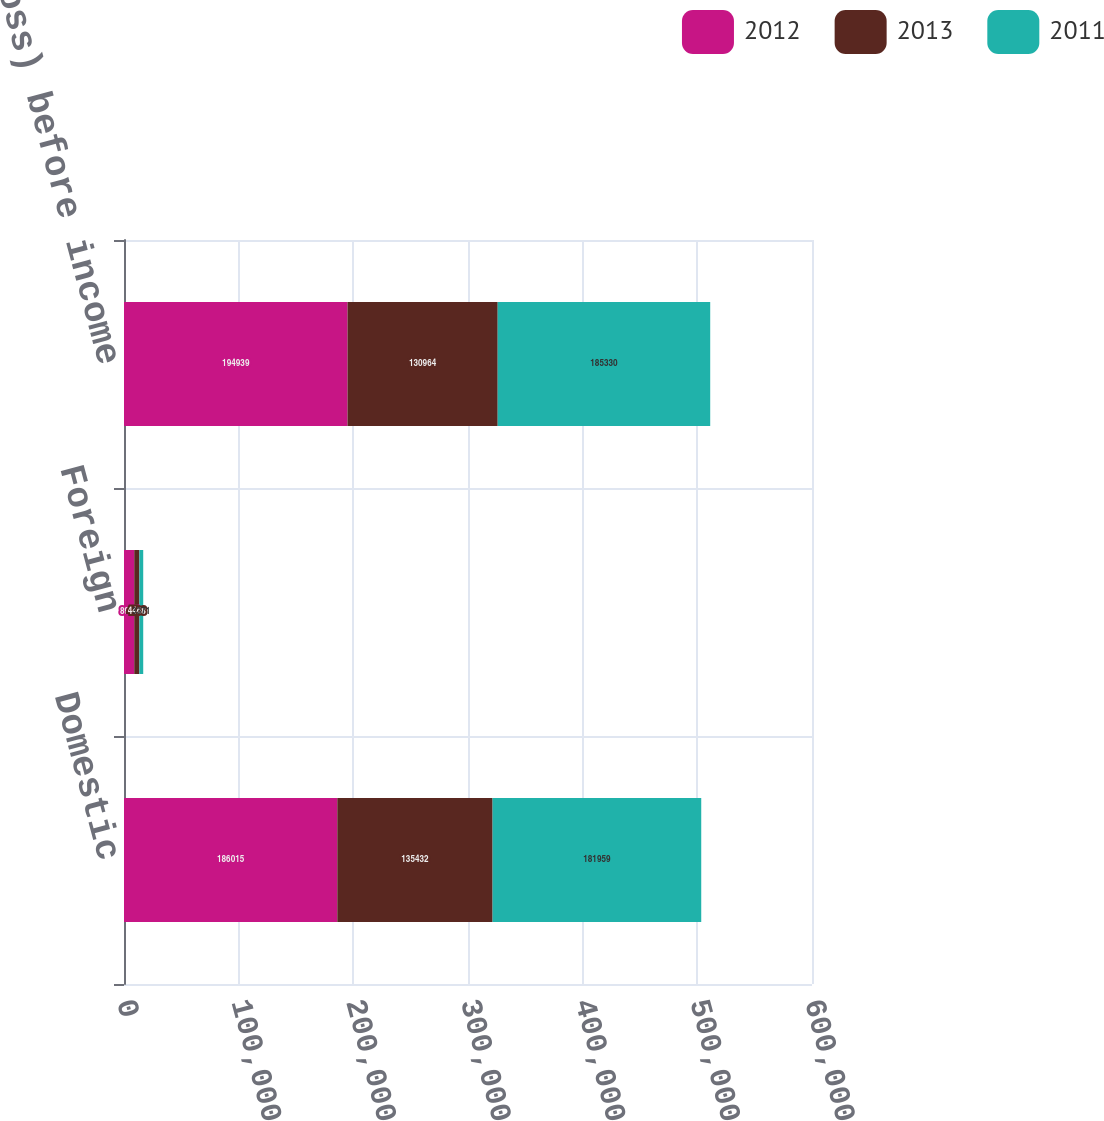<chart> <loc_0><loc_0><loc_500><loc_500><stacked_bar_chart><ecel><fcel>Domestic<fcel>Foreign<fcel>Income (loss) before income<nl><fcel>2012<fcel>186015<fcel>8924<fcel>194939<nl><fcel>2013<fcel>135432<fcel>4468<fcel>130964<nl><fcel>2011<fcel>181959<fcel>3371<fcel>185330<nl></chart> 